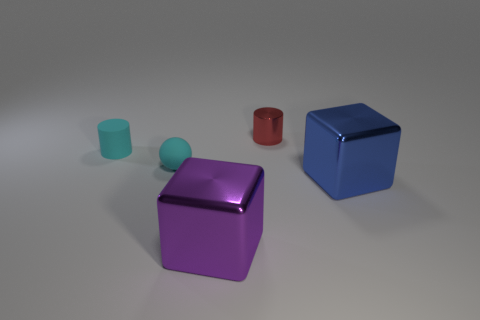What number of large blue objects have the same material as the red cylinder?
Offer a terse response. 1. Is the material of the large block behind the big purple cube the same as the small cyan thing that is to the left of the cyan sphere?
Offer a terse response. No. How many matte balls are on the left side of the tiny object left of the cyan rubber object right of the small matte cylinder?
Provide a short and direct response. 0. Does the cube that is behind the big purple metallic block have the same color as the tiny rubber thing behind the tiny cyan ball?
Make the answer very short. No. Is there anything else that is the same color as the rubber ball?
Keep it short and to the point. Yes. What is the color of the cylinder right of the tiny rubber object that is on the right side of the rubber cylinder?
Give a very brief answer. Red. Are there any big purple objects?
Give a very brief answer. Yes. What is the color of the shiny thing that is both in front of the small cyan matte ball and left of the big blue thing?
Your answer should be very brief. Purple. Is the size of the rubber object to the right of the tiny cyan cylinder the same as the cylinder that is left of the small cyan rubber ball?
Make the answer very short. Yes. How many other things are there of the same size as the red cylinder?
Offer a terse response. 2. 